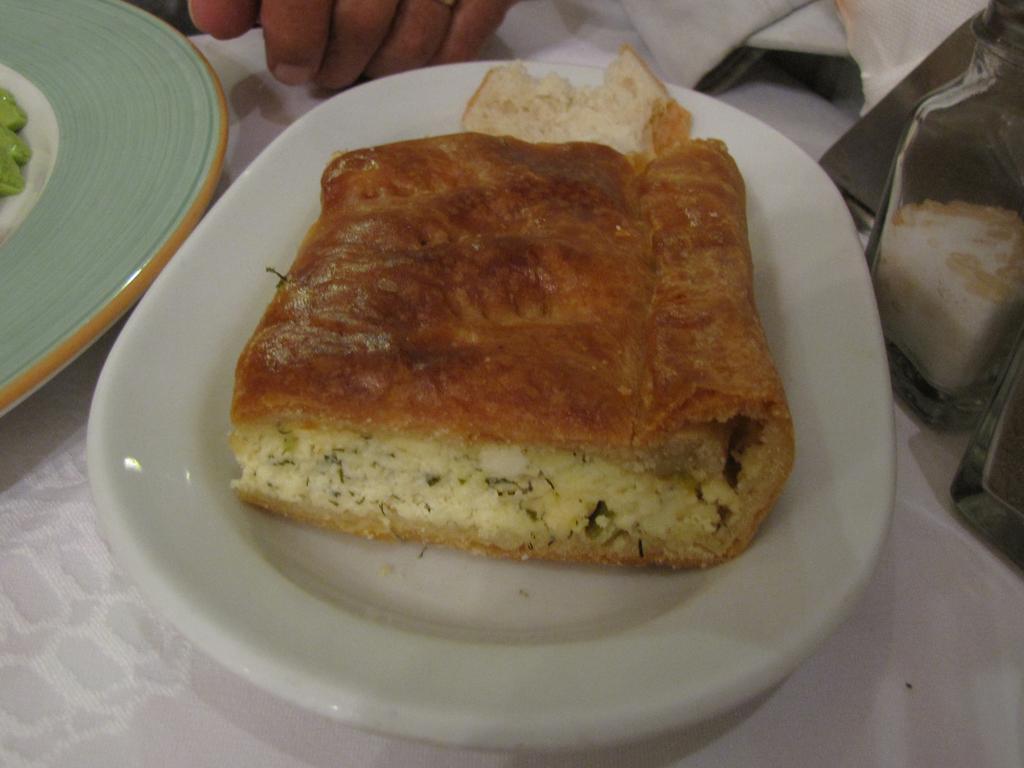In one or two sentences, can you explain what this image depicts? In this image I can see the plates with food. These plates are in white, green and yellow color. And the food is in cream, brown and green color. To the side I can see few more objects. These are on the white color surface. I can also see the person's hand to the side. 